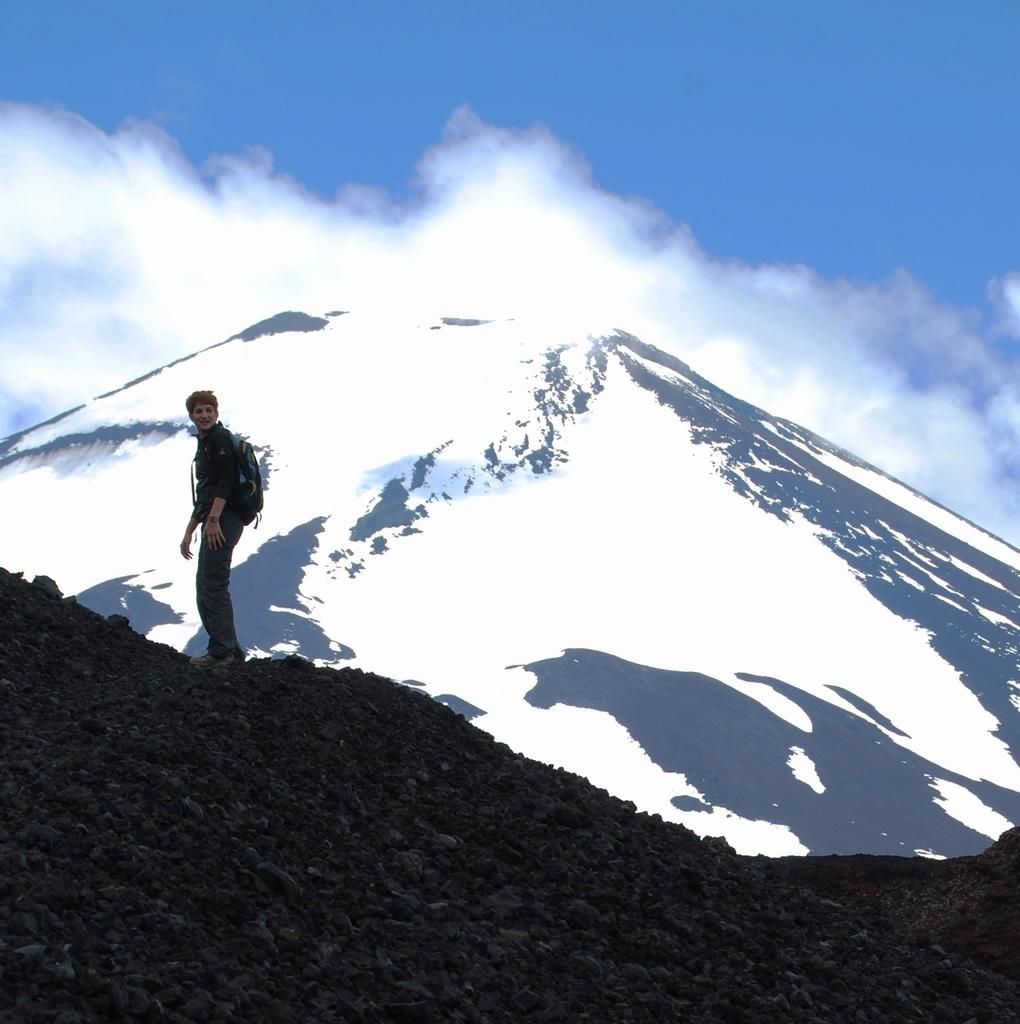What is located on the left side of the image? There is a person standing on the left side of the image. What is the person wearing? The person is wearing a shirt and trousers. What is the person carrying? The person is carrying a bag. What can be seen on the right side of the image? There is a mountain with snow on the right side of the image. What is visible at the top of the image? The sky is visible at the top of the image. What type of cream can be seen on the cushion in the image? There is no cushion or cream present in the image. 